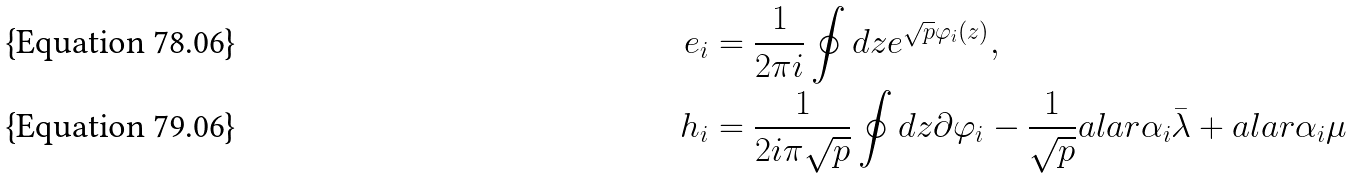<formula> <loc_0><loc_0><loc_500><loc_500>e _ { i } & = \frac { 1 } { 2 \pi i } \oint d z e ^ { \sqrt { p } \varphi _ { i } ( z ) } , \\ h _ { i } & = \frac { 1 } { 2 i \pi \sqrt { p } } \oint d z \partial \varphi _ { i } - \frac { 1 } { \sqrt { p } } a l a r { \alpha _ { i } } { \bar { \lambda } } + a l a r { \alpha _ { i } } { \mu }</formula> 